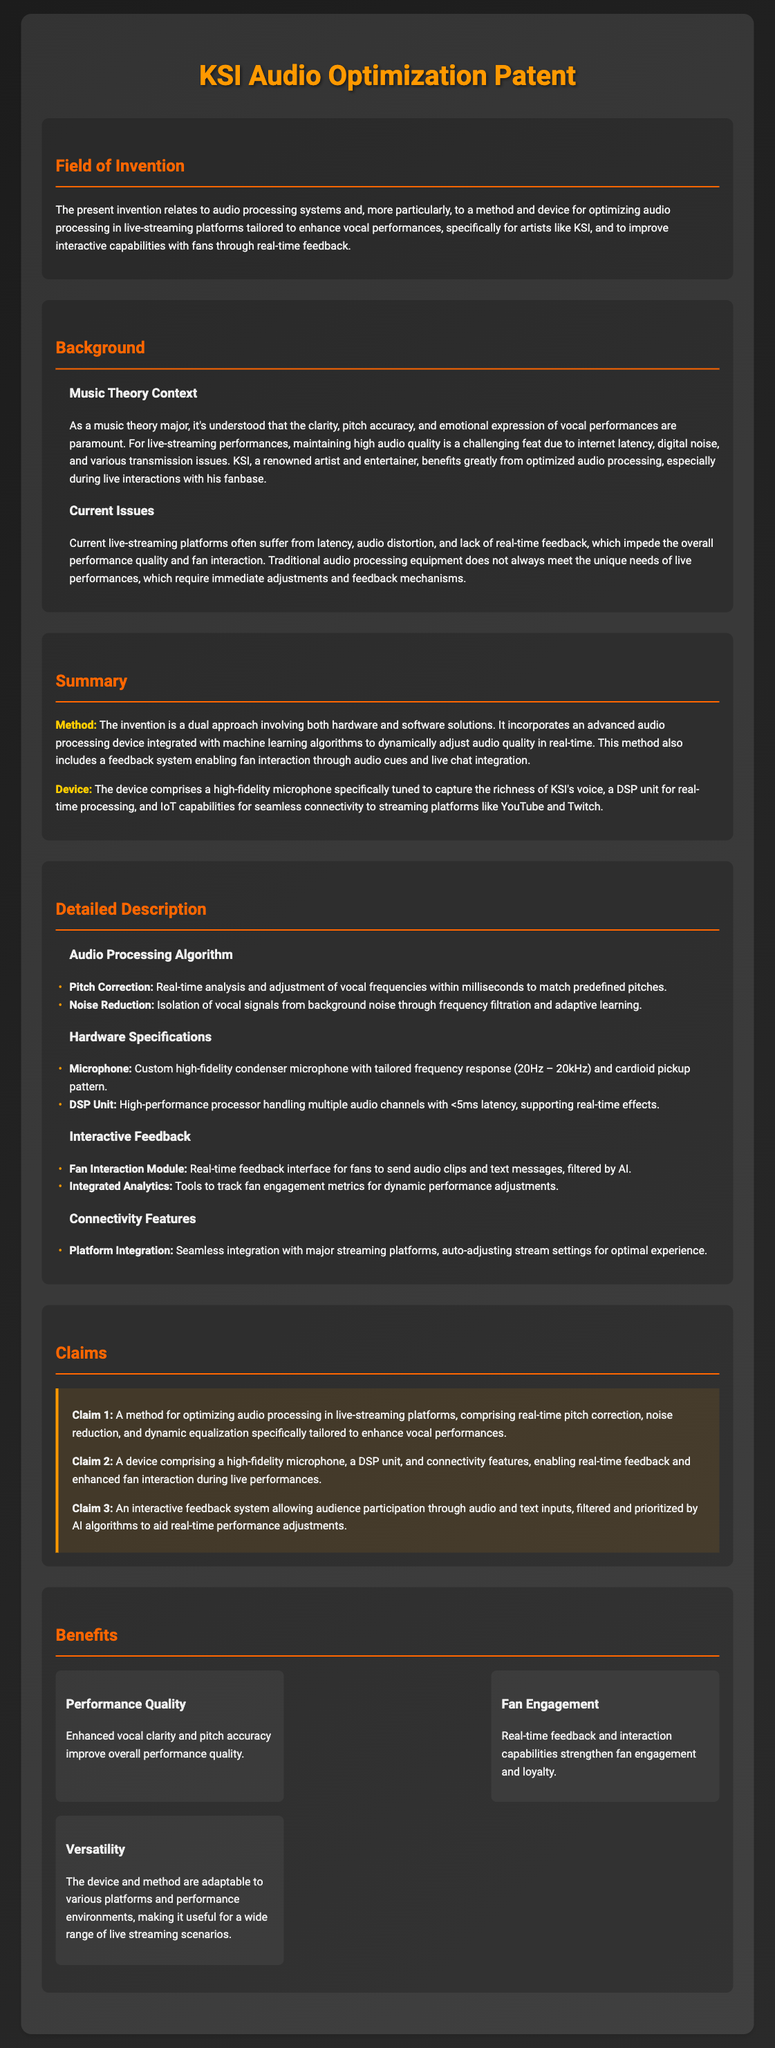What is the focus of the invention? The invention focuses on optimizing audio processing in live-streaming platforms, enhancing vocal performances for artists like KSI.
Answer: optimizing audio processing in live-streaming platforms What are two current issues with live-streaming platforms? The two current issues are latency and audio distortion, affecting performance quality and fan interaction.
Answer: latency and audio distortion What is the unique feature of the microphone used in the device? The microphone is high-fidelity and specifically tuned to capture the richness of KSI's voice.
Answer: specifically tuned to capture the richness of KSI's voice What is included in the interactive feedback system? The interactive feedback system allows audience participation through audio and text inputs, filtered by AI.
Answer: audience participation through audio and text inputs, filtered by AI What is the latency specification of the DSP unit? The DSP unit supports less than 5 milliseconds latency, crucial for real-time processing.
Answer: <5ms latency Which claim mentions the use of AI algorithms? Claim 3 mentions the use of AI algorithms to filter and prioritize audience inputs for performance adjustments.
Answer: Claim 3 What is a benefit of the audio processing method stated in the document? A benefit is improved performance quality through enhanced vocal clarity and pitch accuracy.
Answer: improved performance quality How does the device ensure high-quality audio during streaming? The device ensures high-quality audio through real-time pitch correction, noise reduction, and dynamic equalization.
Answer: real-time pitch correction, noise reduction, dynamic equalization What type of device is introduced in the patent? The patent introduces a method and device aimed at enhancing vocal performance and interactivity with fans.
Answer: a method and device 